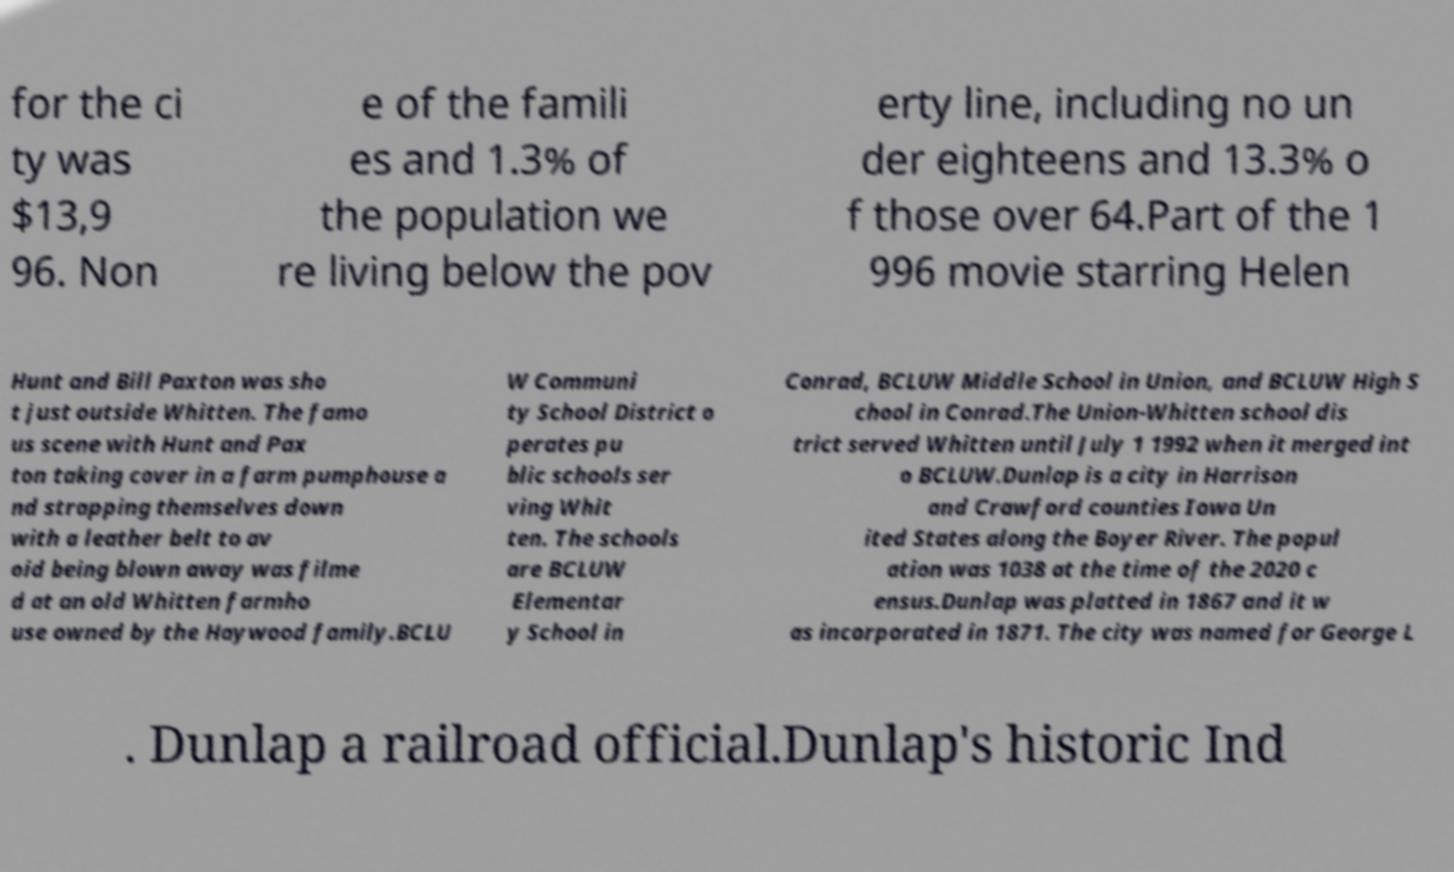What messages or text are displayed in this image? I need them in a readable, typed format. for the ci ty was $13,9 96. Non e of the famili es and 1.3% of the population we re living below the pov erty line, including no un der eighteens and 13.3% o f those over 64.Part of the 1 996 movie starring Helen Hunt and Bill Paxton was sho t just outside Whitten. The famo us scene with Hunt and Pax ton taking cover in a farm pumphouse a nd strapping themselves down with a leather belt to av oid being blown away was filme d at an old Whitten farmho use owned by the Haywood family.BCLU W Communi ty School District o perates pu blic schools ser ving Whit ten. The schools are BCLUW Elementar y School in Conrad, BCLUW Middle School in Union, and BCLUW High S chool in Conrad.The Union-Whitten school dis trict served Whitten until July 1 1992 when it merged int o BCLUW.Dunlap is a city in Harrison and Crawford counties Iowa Un ited States along the Boyer River. The popul ation was 1038 at the time of the 2020 c ensus.Dunlap was platted in 1867 and it w as incorporated in 1871. The city was named for George L . Dunlap a railroad official.Dunlap's historic Ind 